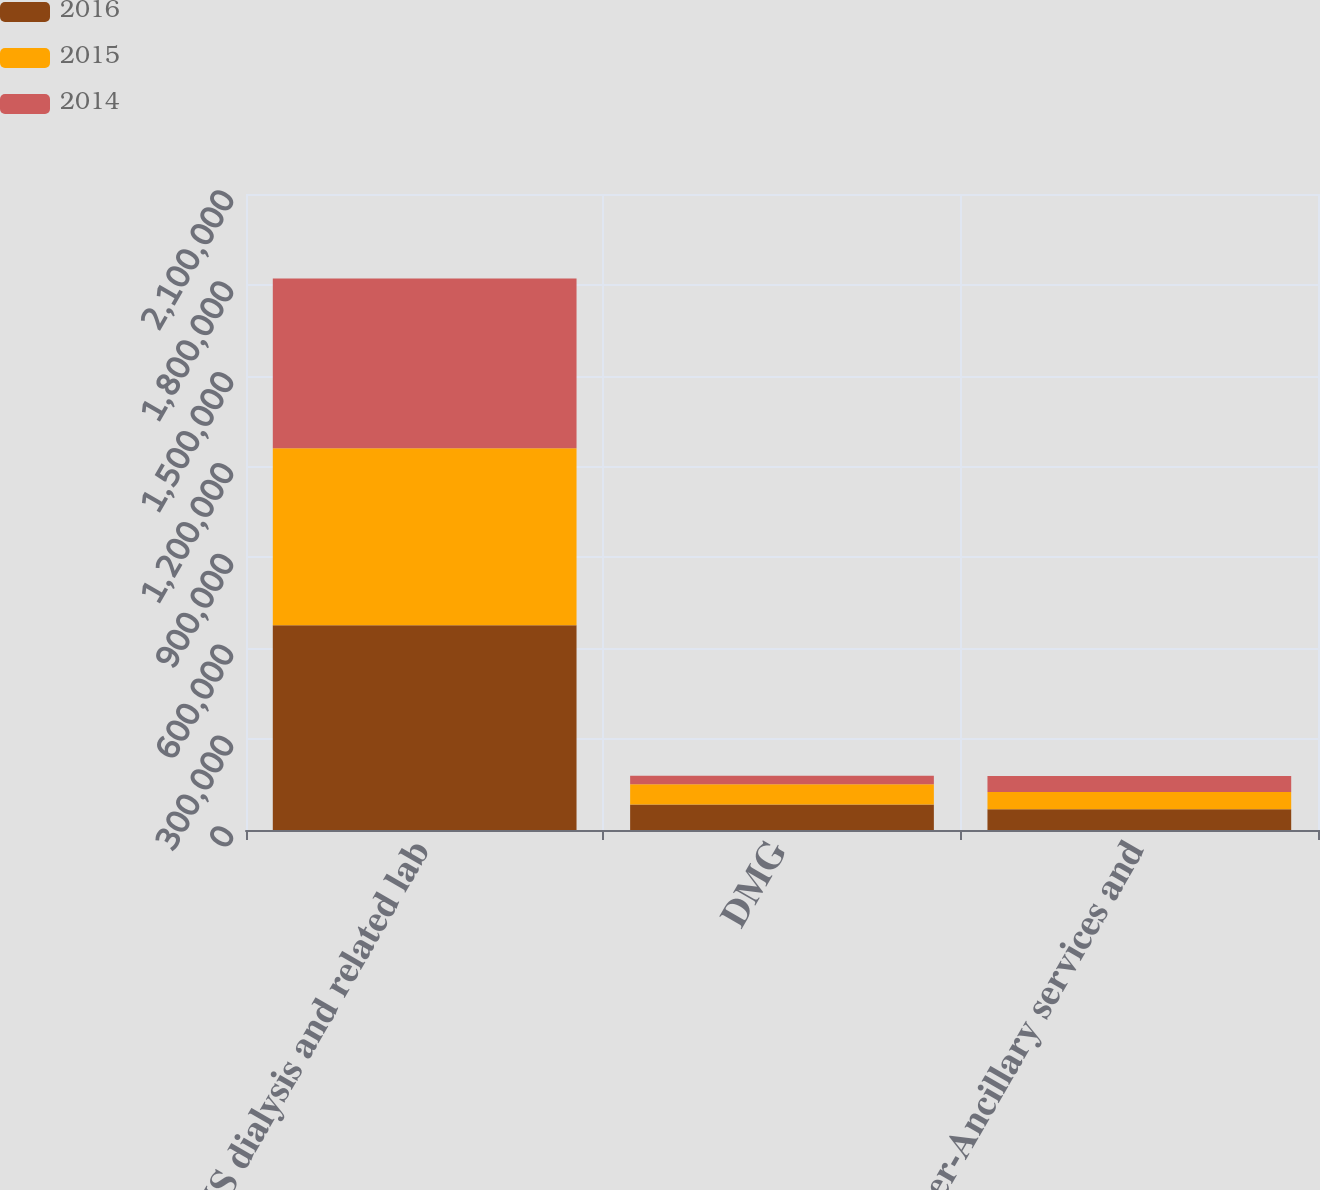<chart> <loc_0><loc_0><loc_500><loc_500><stacked_bar_chart><ecel><fcel>US dialysis and related lab<fcel>DMG<fcel>Other-Ancillary services and<nl><fcel>2016<fcel>675994<fcel>84399<fcel>68702<nl><fcel>2015<fcel>584513<fcel>66800<fcel>56685<nl><fcel>2014<fcel>560610<fcel>27885<fcel>52835<nl></chart> 